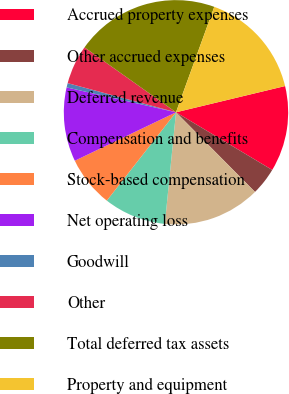<chart> <loc_0><loc_0><loc_500><loc_500><pie_chart><fcel>Accrued property expenses<fcel>Other accrued expenses<fcel>Deferred revenue<fcel>Compensation and benefits<fcel>Stock-based compensation<fcel>Net operating loss<fcel>Goodwill<fcel>Other<fcel>Total deferred tax assets<fcel>Property and equipment<nl><fcel>12.35%<fcel>3.97%<fcel>14.02%<fcel>8.99%<fcel>7.32%<fcel>10.67%<fcel>0.62%<fcel>5.64%<fcel>20.72%<fcel>15.7%<nl></chart> 